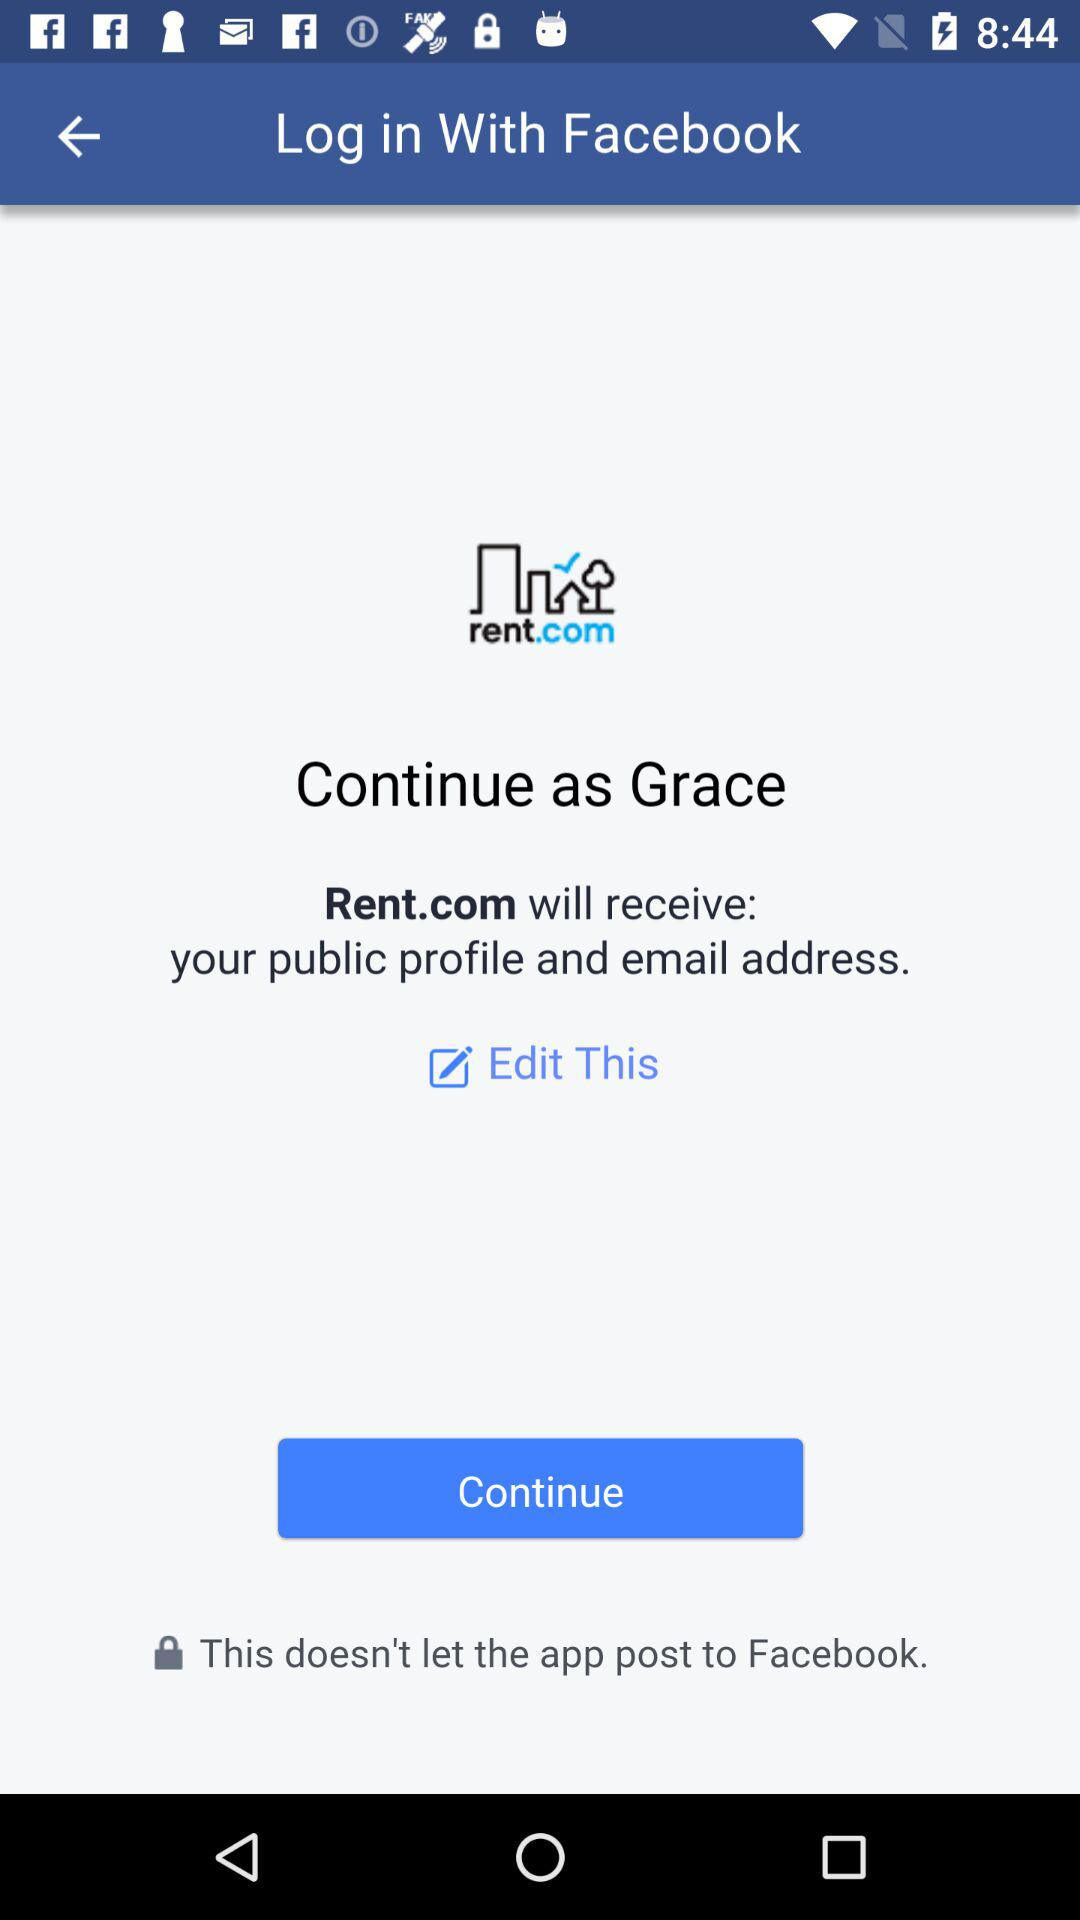What is the user name? The user name is Grace. 